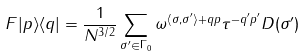Convert formula to latex. <formula><loc_0><loc_0><loc_500><loc_500>F | p \rangle \langle q | = \frac { 1 } { N ^ { 3 / 2 } } \sum _ { \sigma ^ { \prime } \in \Gamma _ { 0 } } \omega ^ { \langle \sigma , \sigma ^ { \prime } \rangle + q p } \tau ^ { - q ^ { \prime } p ^ { \prime } } D ( \sigma ^ { \prime } )</formula> 